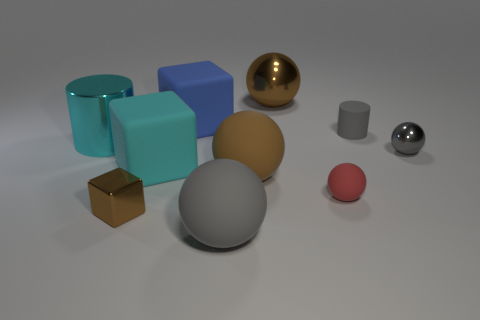What material is the small object that is the same color as the rubber cylinder?
Keep it short and to the point. Metal. How many metal cubes are there?
Provide a short and direct response. 1. Is the number of gray balls less than the number of green rubber objects?
Keep it short and to the point. No. What is the material of the gray sphere that is the same size as the cyan matte object?
Give a very brief answer. Rubber. How many objects are either big blue rubber blocks or large gray spheres?
Offer a terse response. 2. What number of tiny things are to the left of the gray metallic sphere and right of the red rubber ball?
Offer a terse response. 1. Are there fewer large brown metal balls on the left side of the brown cube than big matte spheres?
Your answer should be compact. Yes. What shape is the shiny thing that is the same size as the shiny block?
Provide a succinct answer. Sphere. What number of other objects are there of the same color as the large shiny sphere?
Your answer should be compact. 2. Is the cyan cylinder the same size as the brown matte sphere?
Your answer should be compact. Yes. 